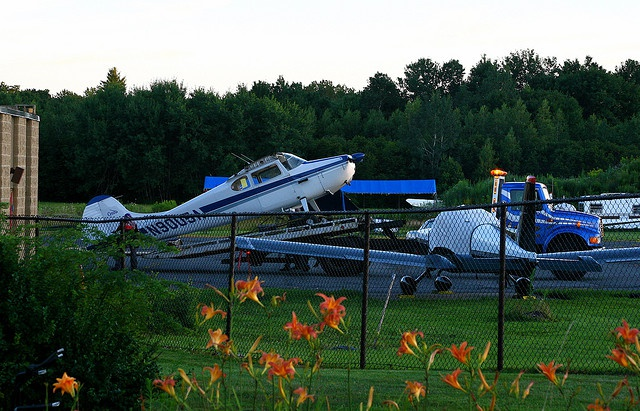Describe the objects in this image and their specific colors. I can see airplane in white, gray, black, and navy tones, airplane in white, black, navy, and blue tones, truck in white, black, navy, darkblue, and blue tones, and people in white, black, darkgreen, navy, and gray tones in this image. 